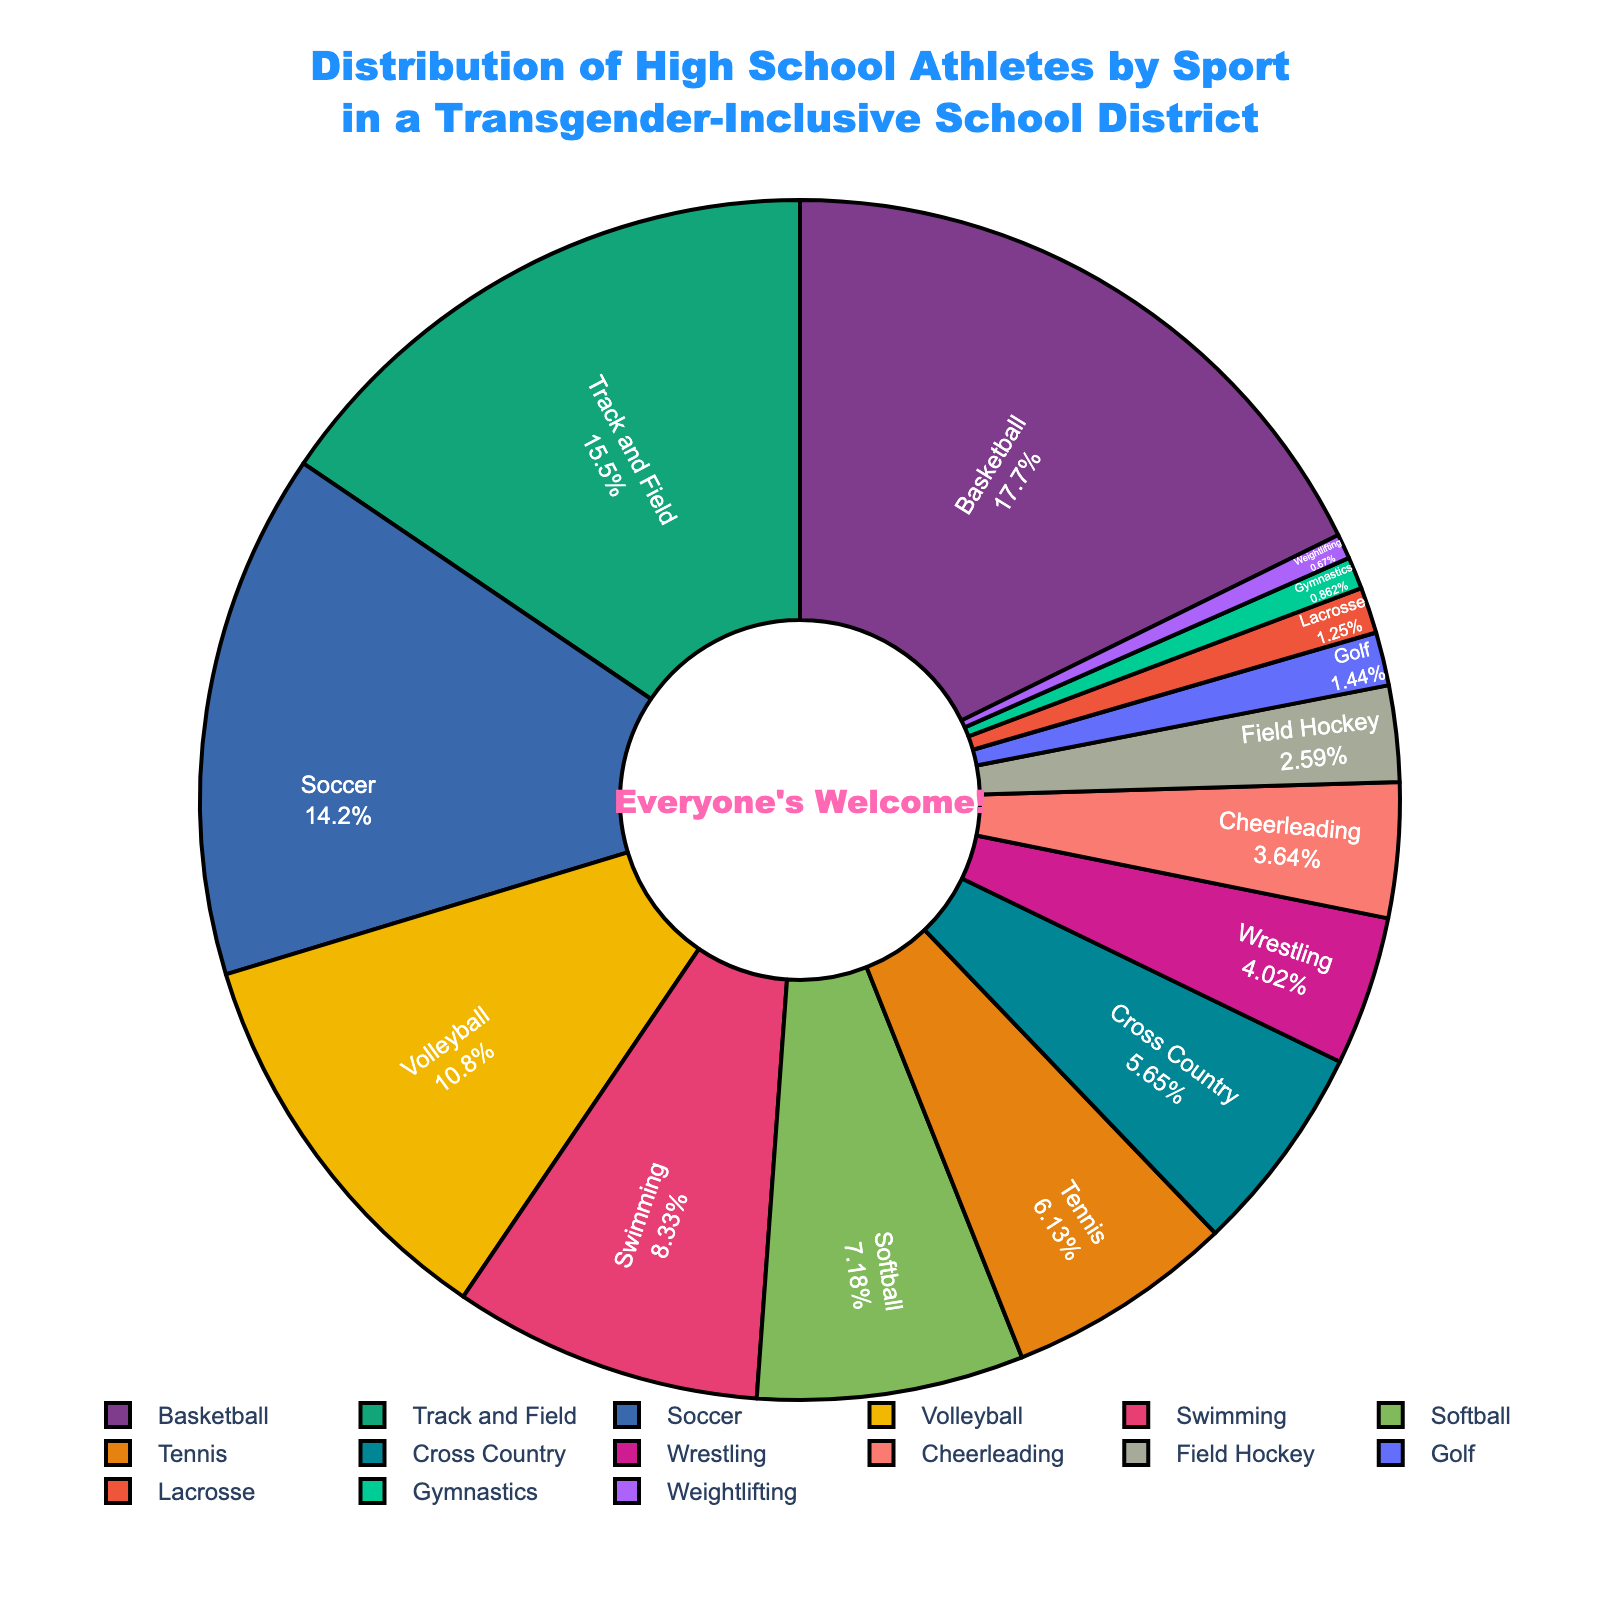What sport has the highest percentage of athletes? The sport with the highest percentage of athletes is identified by the largest segment of the pie chart. In this case, the segment labeled "Basketball" is the largest.
Answer: Basketball Which two sports combined have the closest percentage to Volleyball? Volleyball has a percentage of 11.3. The sports with percentages closest to 11.3 are Softball (7.5) and Cross Country (5.9). Adding their percentages: 7.5 + 5.9 = 13.4, which is closest to 11.3.
Answer: Softball and Cross Country Which sport has a slightly lower percentage than Soccer? Soccer has a percentage of 14.8. The next slightly lower percentage is Track and Field with 16.2.
Answer: Track and Field How many sports have a percentage lower than 3%? By looking at the segments of the pie chart with percentages lower than 3%, we identify Field Hockey (2.7), Lacrosse (1.3), and Gymnastics (0.9), and Weightlifting (0.7). There are 4 sports in total.
Answer: 4 What is the difference in percentage between Swimming and Wrestling? Swimming has a percentage of 8.7, and Wrestling has a percentage of 4.2. The difference is 8.7 - 4.2 = 4.5.
Answer: 4.5 Which sport has the smallest representation of athletes? The smallest segment on the pie chart represents the sport with the lowest percentage, which is Weightlifting at 0.7%.
Answer: Weightlifting If you compare Soccer and Tennis, which sport has a larger percentage, and by how much? Soccer has a percentage of 14.8, and Tennis has 6.4. The difference is 14.8 - 6.4 = 8.4, so Soccer has a larger percentage by 8.4.
Answer: Soccer by 8.4 Which sports have a combined percentage of over 30% when added together? Sports that cumulatively exceed 30% can be found by summing their percentages. Basketball (18.5), Track and Field (16.2), and Soccer (14.8) together equal 18.5 + 16.2 + 14.8 = 49.5, which is over 30%.
Answer: Basketball, Track and Field, and Soccer What is the median percentage value for the sports listed? To find the median, list the sports' percentages in ascending order and find the middle value. The percentages are 0.7, 0.9, 1.3, 1.5, 2.7, 3.8, 4.2, 5.9, 6.4, 7.5, 8.7, 11.3, 14.8, 16.2, 18.5. The median value in this sorted list is 6.4.
Answer: 6.4 